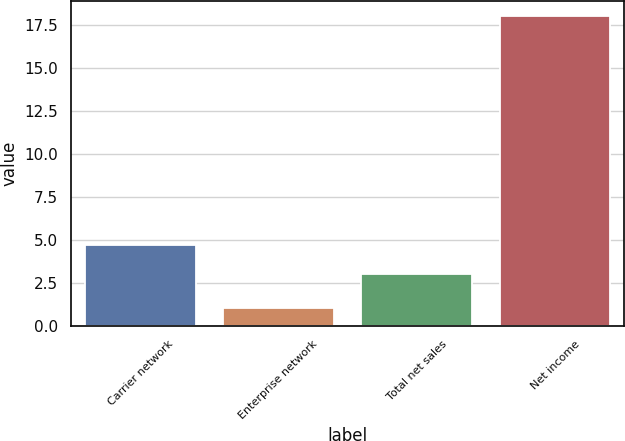Convert chart to OTSL. <chart><loc_0><loc_0><loc_500><loc_500><bar_chart><fcel>Carrier network<fcel>Enterprise network<fcel>Total net sales<fcel>Net income<nl><fcel>4.7<fcel>1<fcel>3<fcel>18<nl></chart> 